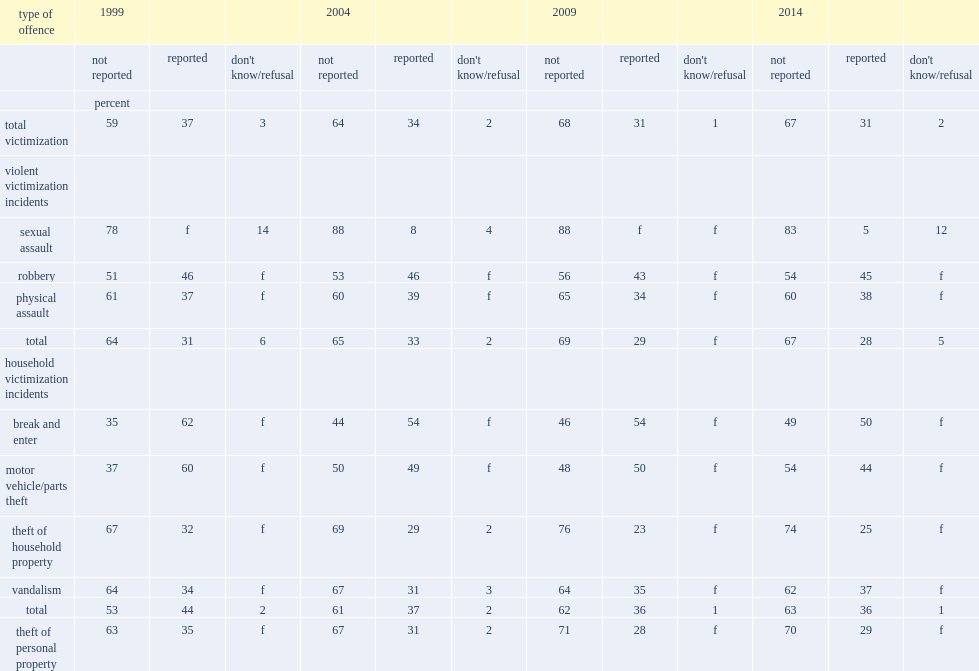How many per cent of the thefts of personal property were brought to the attention of the police in 2014? 29. What was the proportion of incidents reported to police in 2004? 34. What was the proportion of incidents reported to police in 2014? 31. 